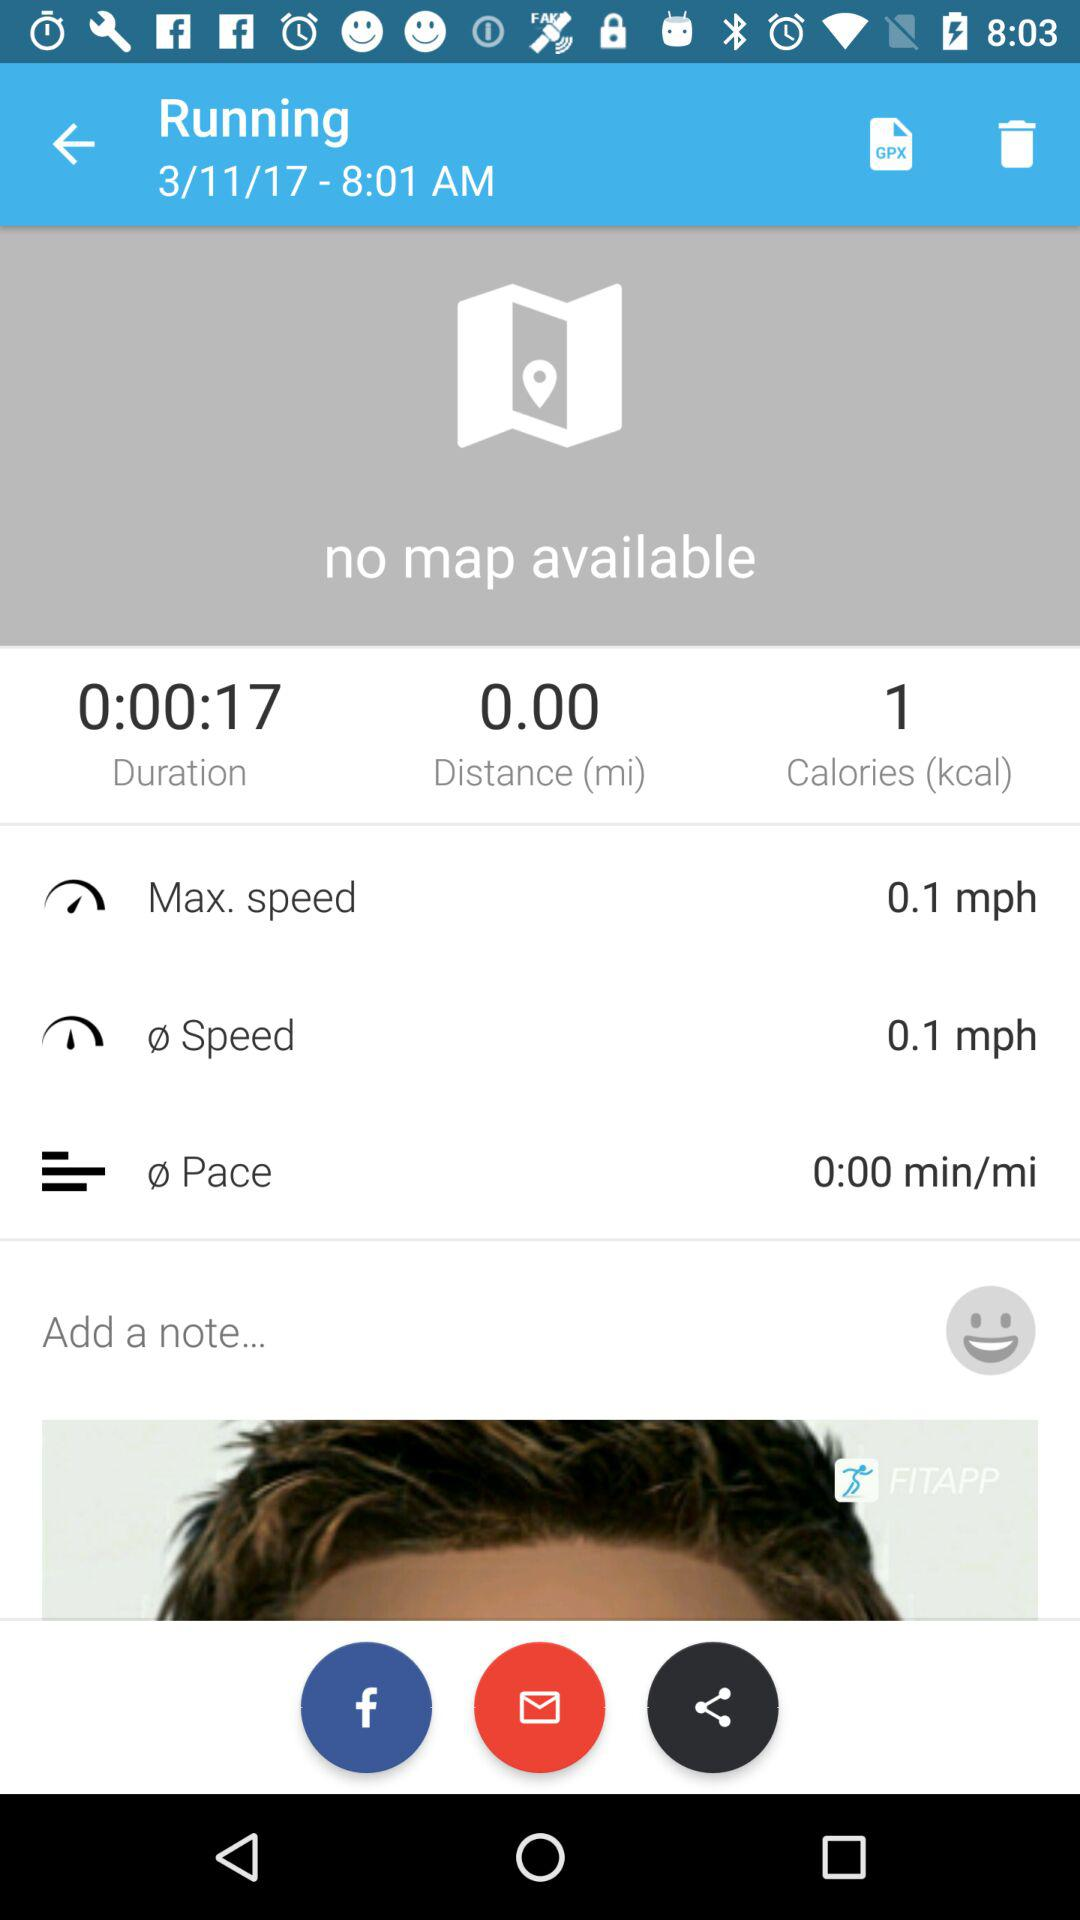In which category is 0.00 miles selected? 0.00 miles is selected in the "Distance" category. 